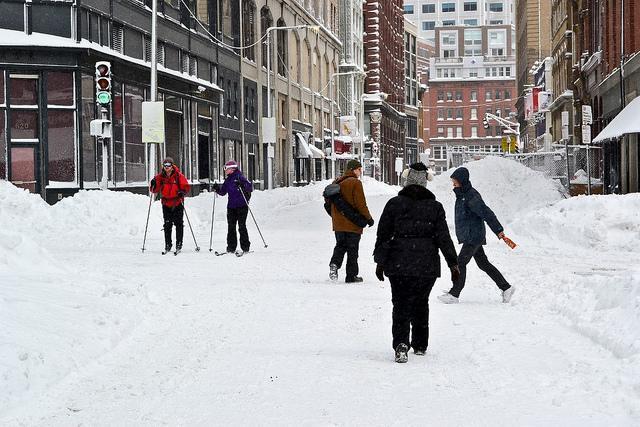How many people are there?
Give a very brief answer. 5. How many chairs are there?
Give a very brief answer. 0. 